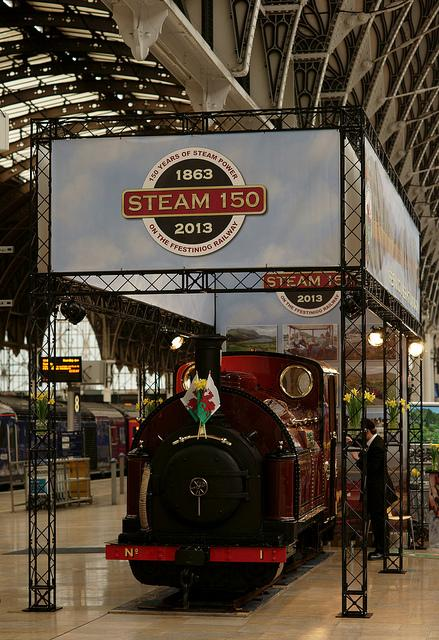What operation should be done with the numbers to arrive at the years of steam power? Please explain your reasoning. subtraction. To tell a difference of years, you take the smaller number from the bigger number. 